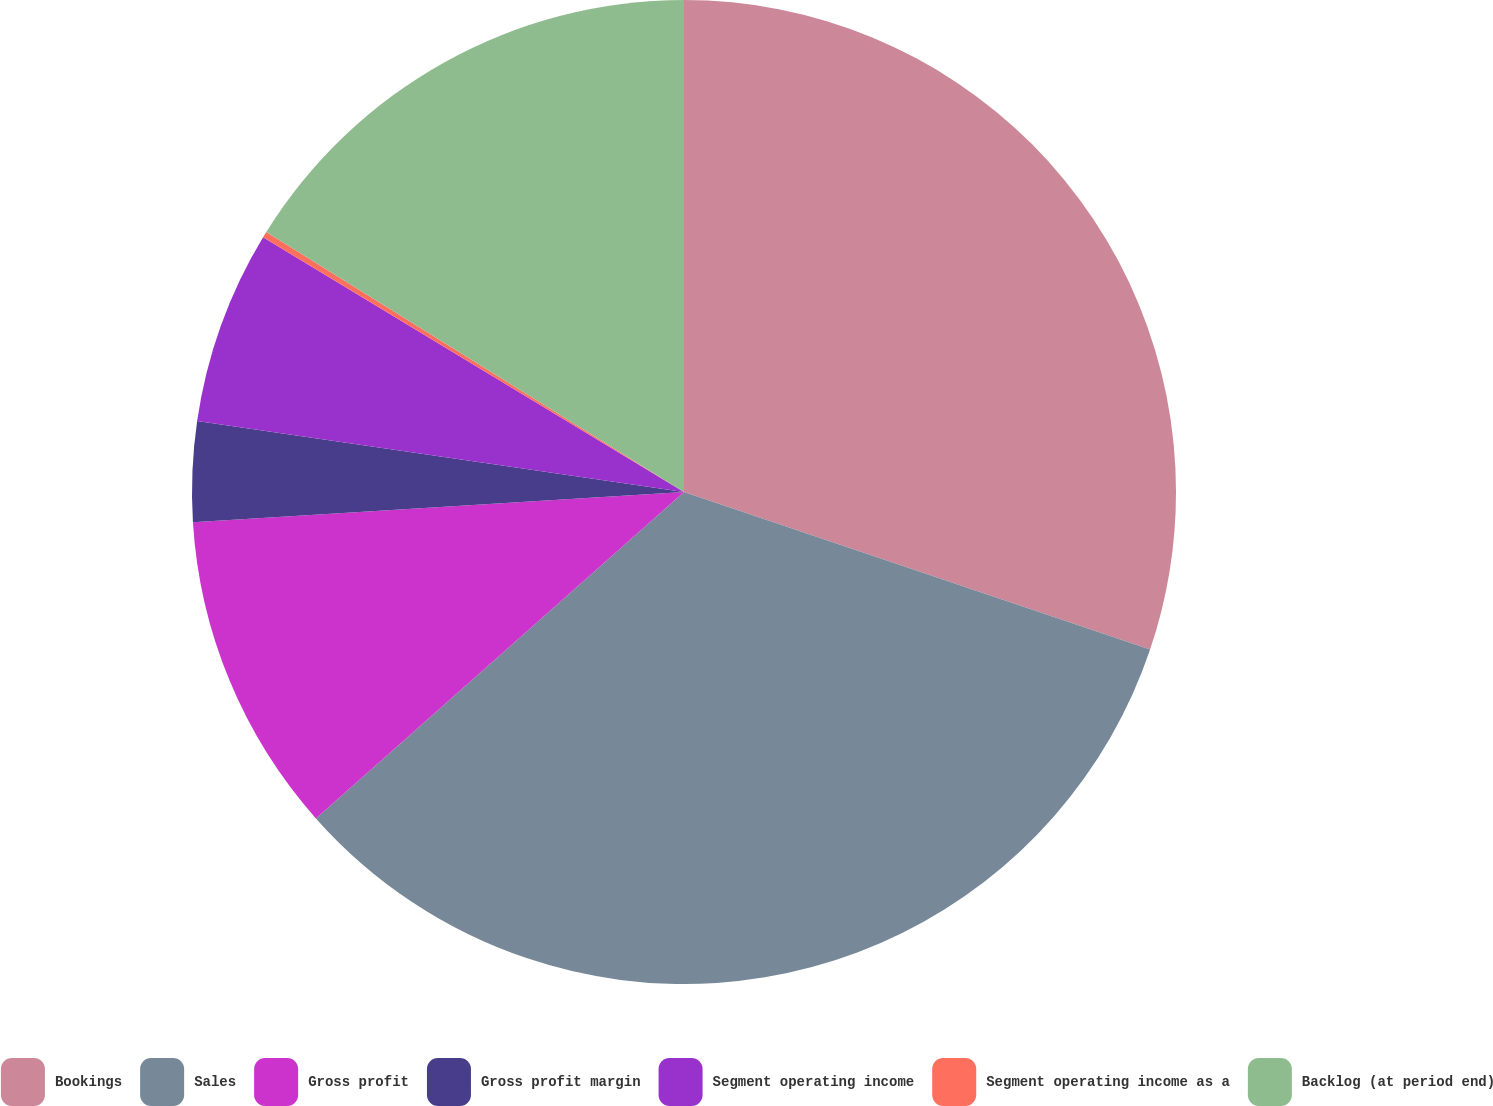<chart> <loc_0><loc_0><loc_500><loc_500><pie_chart><fcel>Bookings<fcel>Sales<fcel>Gross profit<fcel>Gross profit margin<fcel>Segment operating income<fcel>Segment operating income as a<fcel>Backlog (at period end)<nl><fcel>30.19%<fcel>33.27%<fcel>10.57%<fcel>3.28%<fcel>6.36%<fcel>0.2%<fcel>16.14%<nl></chart> 